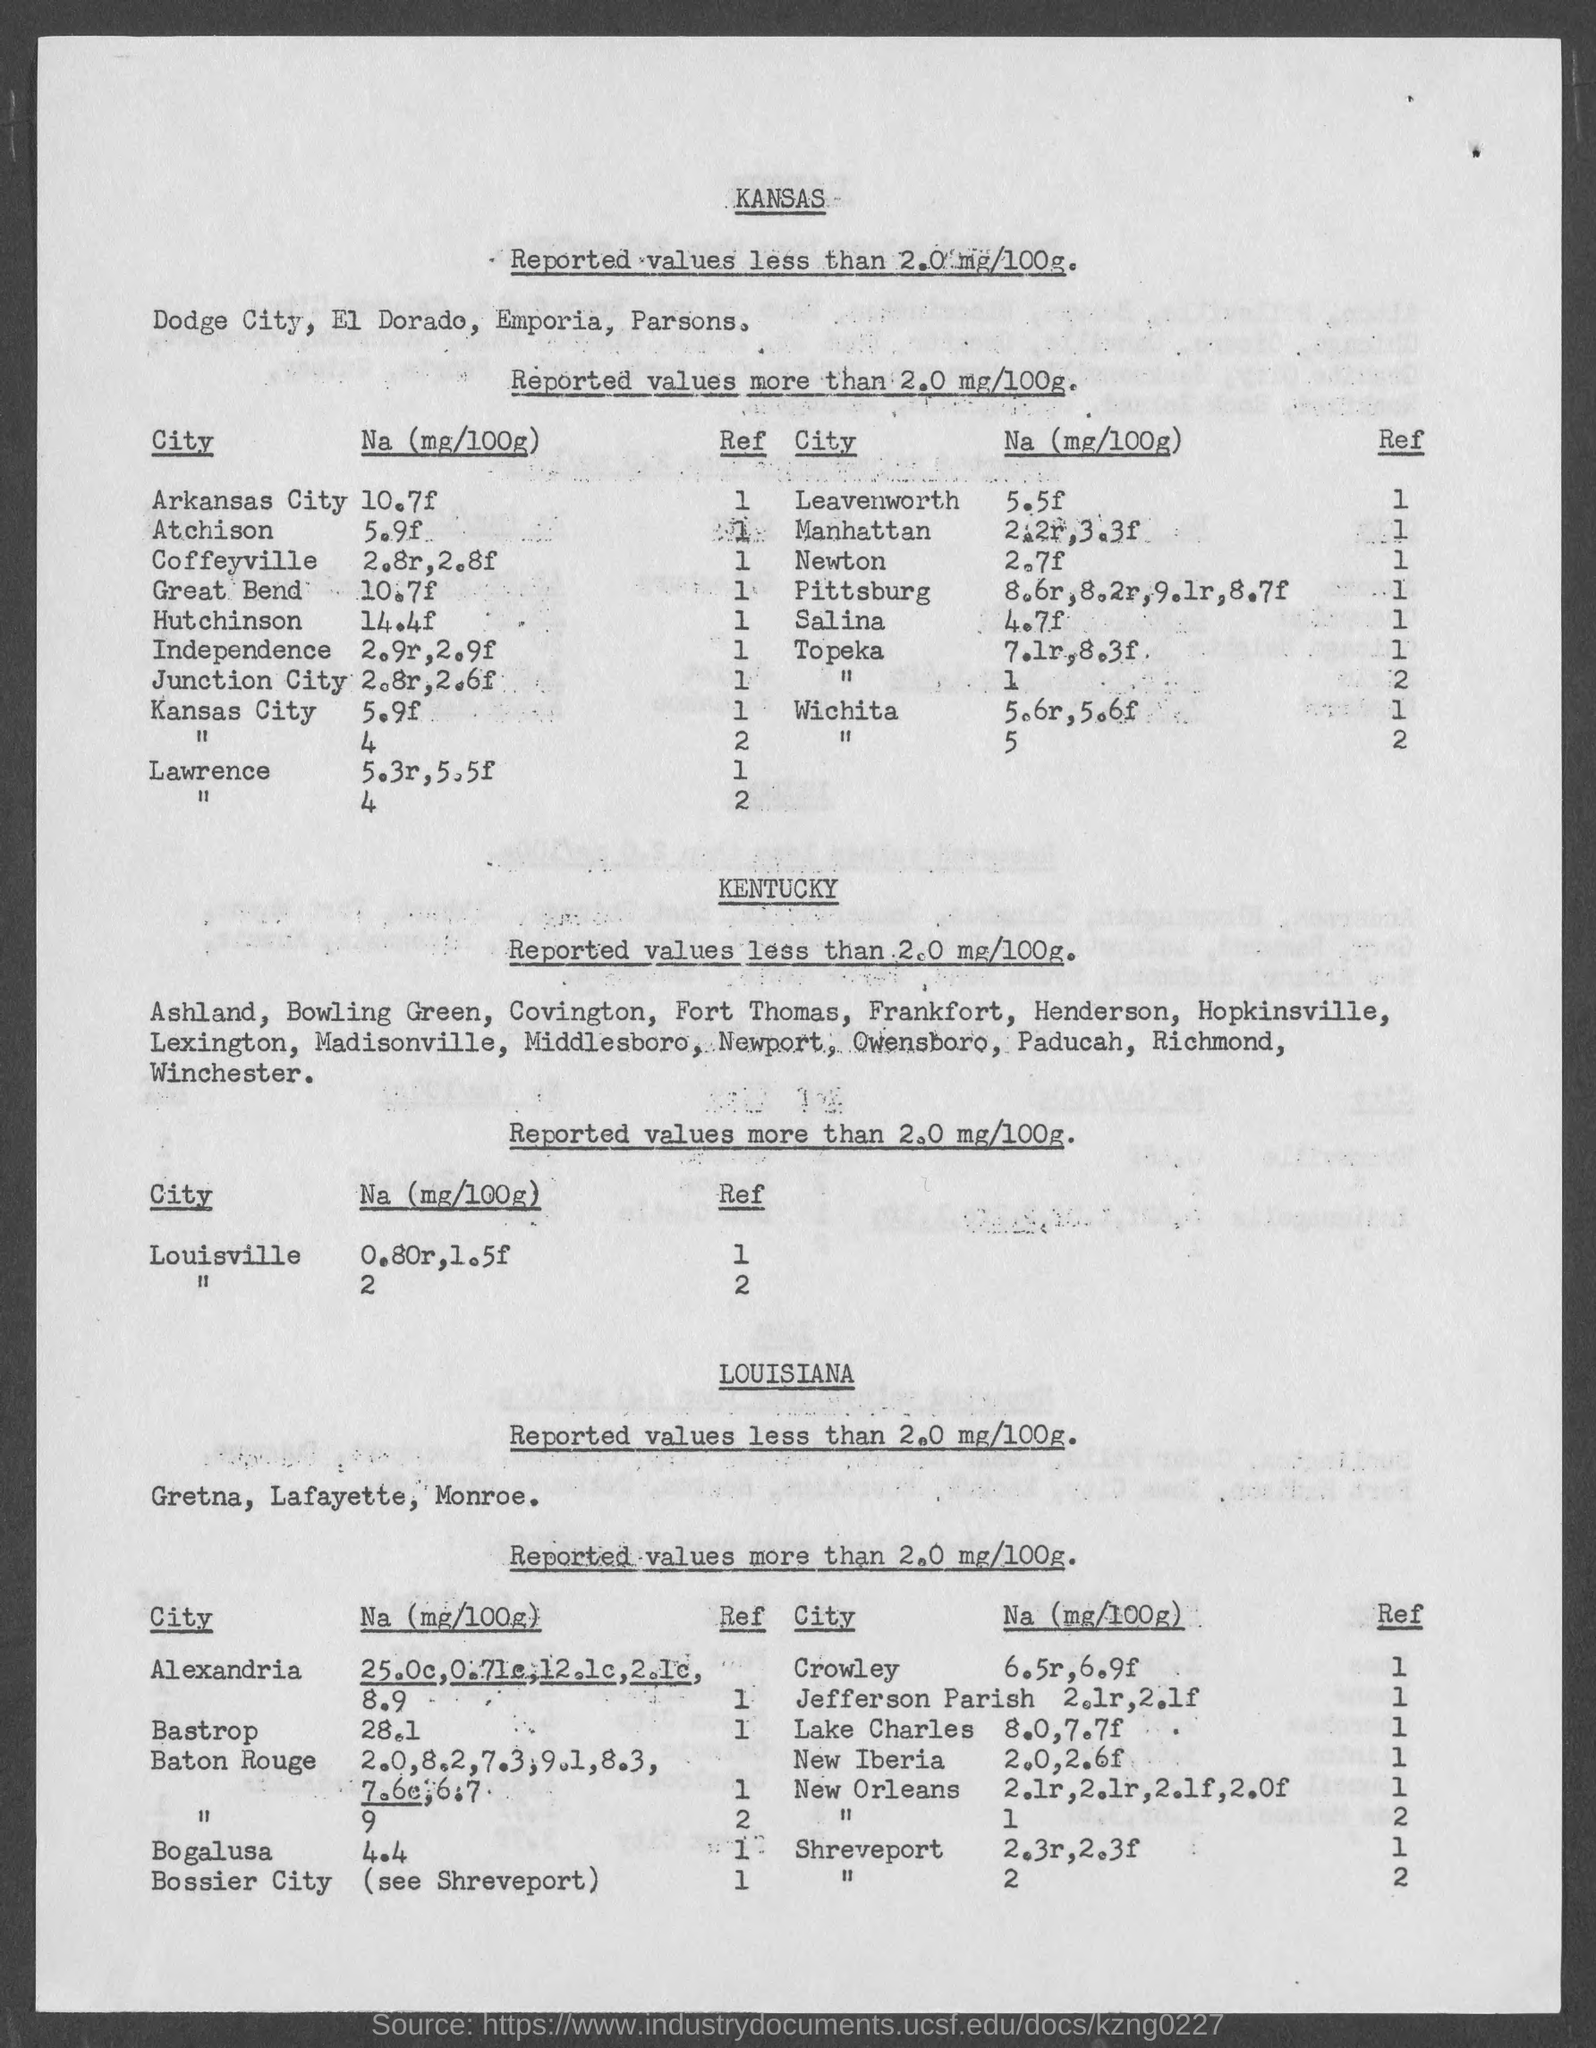List a handful of essential elements in this visual. The value of Na (sodium) in 100 grams in Great Bend is approximately 10.7 milligrams. The value of Na (sodium) in Arkansas City is 10.7 times the concentration of sodium in freshwater. The average concentration of sodium in Kansas City is 5.9 milligrams per 100 grams. In a salt solution, the concentration of sodium (Na) is 4.7 times greater than the concentration of magnesium (Mg) per 100 grams. Na(mg/100g) in Leavenworth is approximately 5.5, where Na represents sodium and mg represents milligrams. 